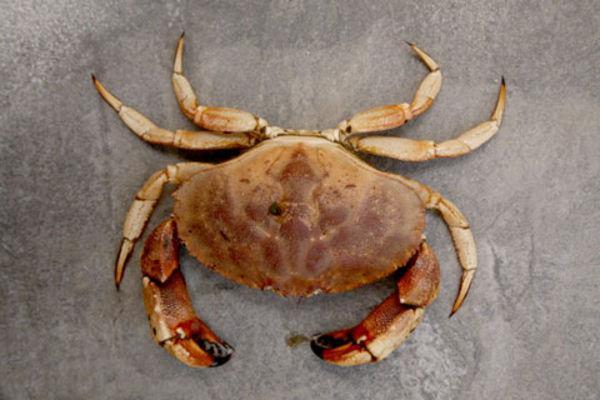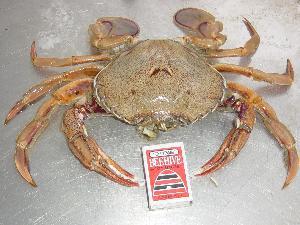The first image is the image on the left, the second image is the image on the right. For the images displayed, is the sentence "The crabs are facing in opposite directions" factually correct? Answer yes or no. No. 